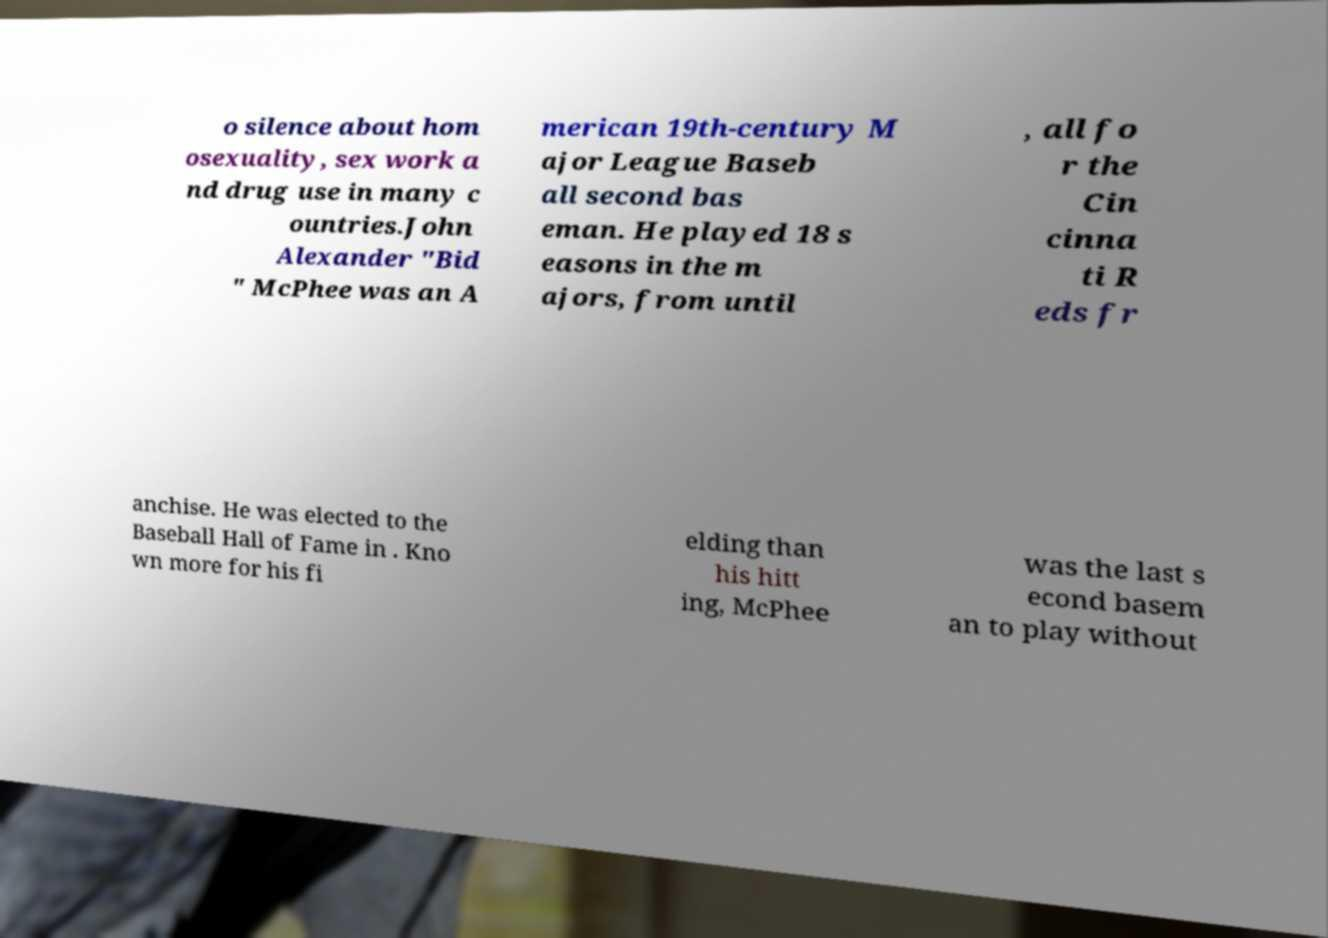There's text embedded in this image that I need extracted. Can you transcribe it verbatim? o silence about hom osexuality, sex work a nd drug use in many c ountries.John Alexander "Bid " McPhee was an A merican 19th-century M ajor League Baseb all second bas eman. He played 18 s easons in the m ajors, from until , all fo r the Cin cinna ti R eds fr anchise. He was elected to the Baseball Hall of Fame in . Kno wn more for his fi elding than his hitt ing, McPhee was the last s econd basem an to play without 